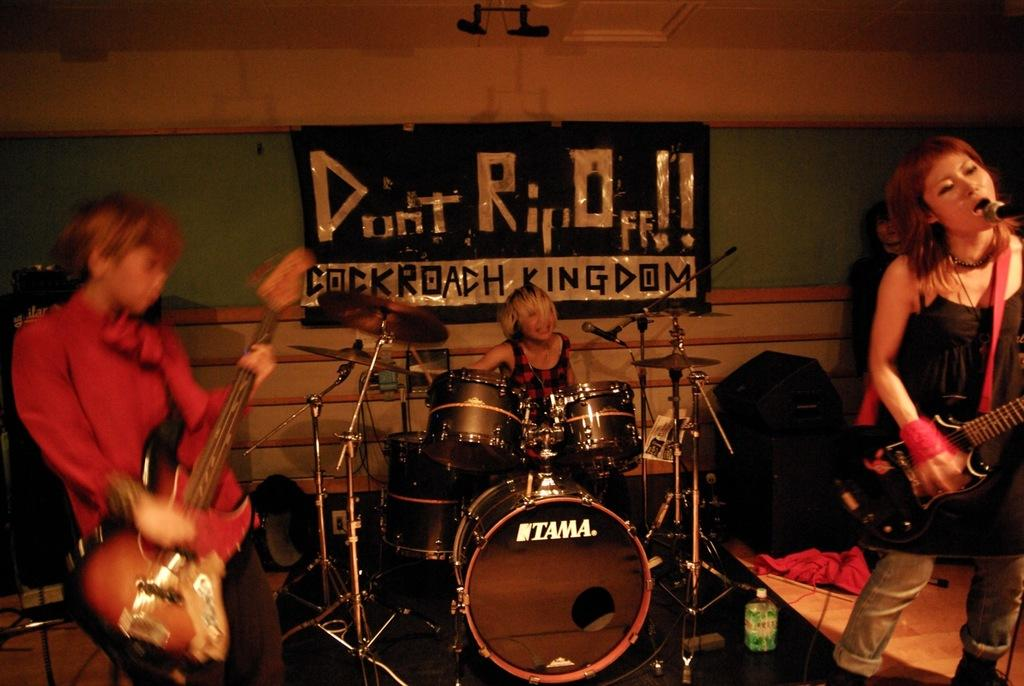What type of structure can be seen in the image? There is a wall in the image. What is hanging on the wall? There is a banner in the image. Are there any people in the image? Yes, there are people in the image. What musical instruments are present in the image? Musical drums and guitars are visible in the image. Can you see the partner holding a rose in the image? There is no partner or rose present in the image. What is the weather like in the image, considering it's summer? The facts provided do not mention the weather or the season, so we cannot determine if it's summer or what the weather is like in the image. 